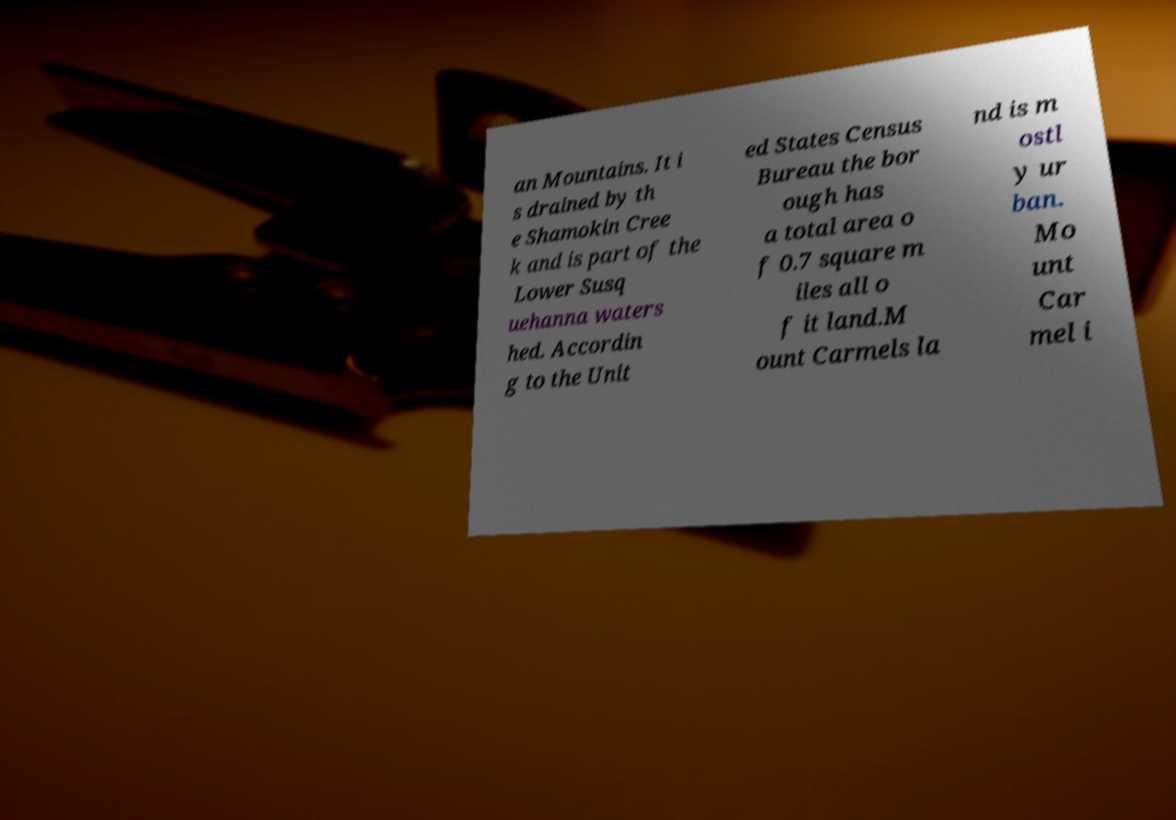Please read and relay the text visible in this image. What does it say? an Mountains. It i s drained by th e Shamokin Cree k and is part of the Lower Susq uehanna waters hed. Accordin g to the Unit ed States Census Bureau the bor ough has a total area o f 0.7 square m iles all o f it land.M ount Carmels la nd is m ostl y ur ban. Mo unt Car mel i 